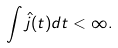<formula> <loc_0><loc_0><loc_500><loc_500>\int \hat { j } ( t ) d t < \infty .</formula> 